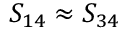<formula> <loc_0><loc_0><loc_500><loc_500>S _ { 1 4 } \approx S _ { 3 4 }</formula> 